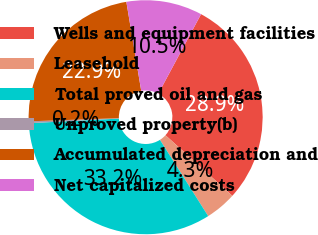Convert chart to OTSL. <chart><loc_0><loc_0><loc_500><loc_500><pie_chart><fcel>Wells and equipment facilities<fcel>Leasehold<fcel>Total proved oil and gas<fcel>Unproved property(b)<fcel>Accumulated depreciation and<fcel>Net capitalized costs<nl><fcel>28.87%<fcel>4.3%<fcel>33.17%<fcel>0.25%<fcel>22.93%<fcel>10.49%<nl></chart> 